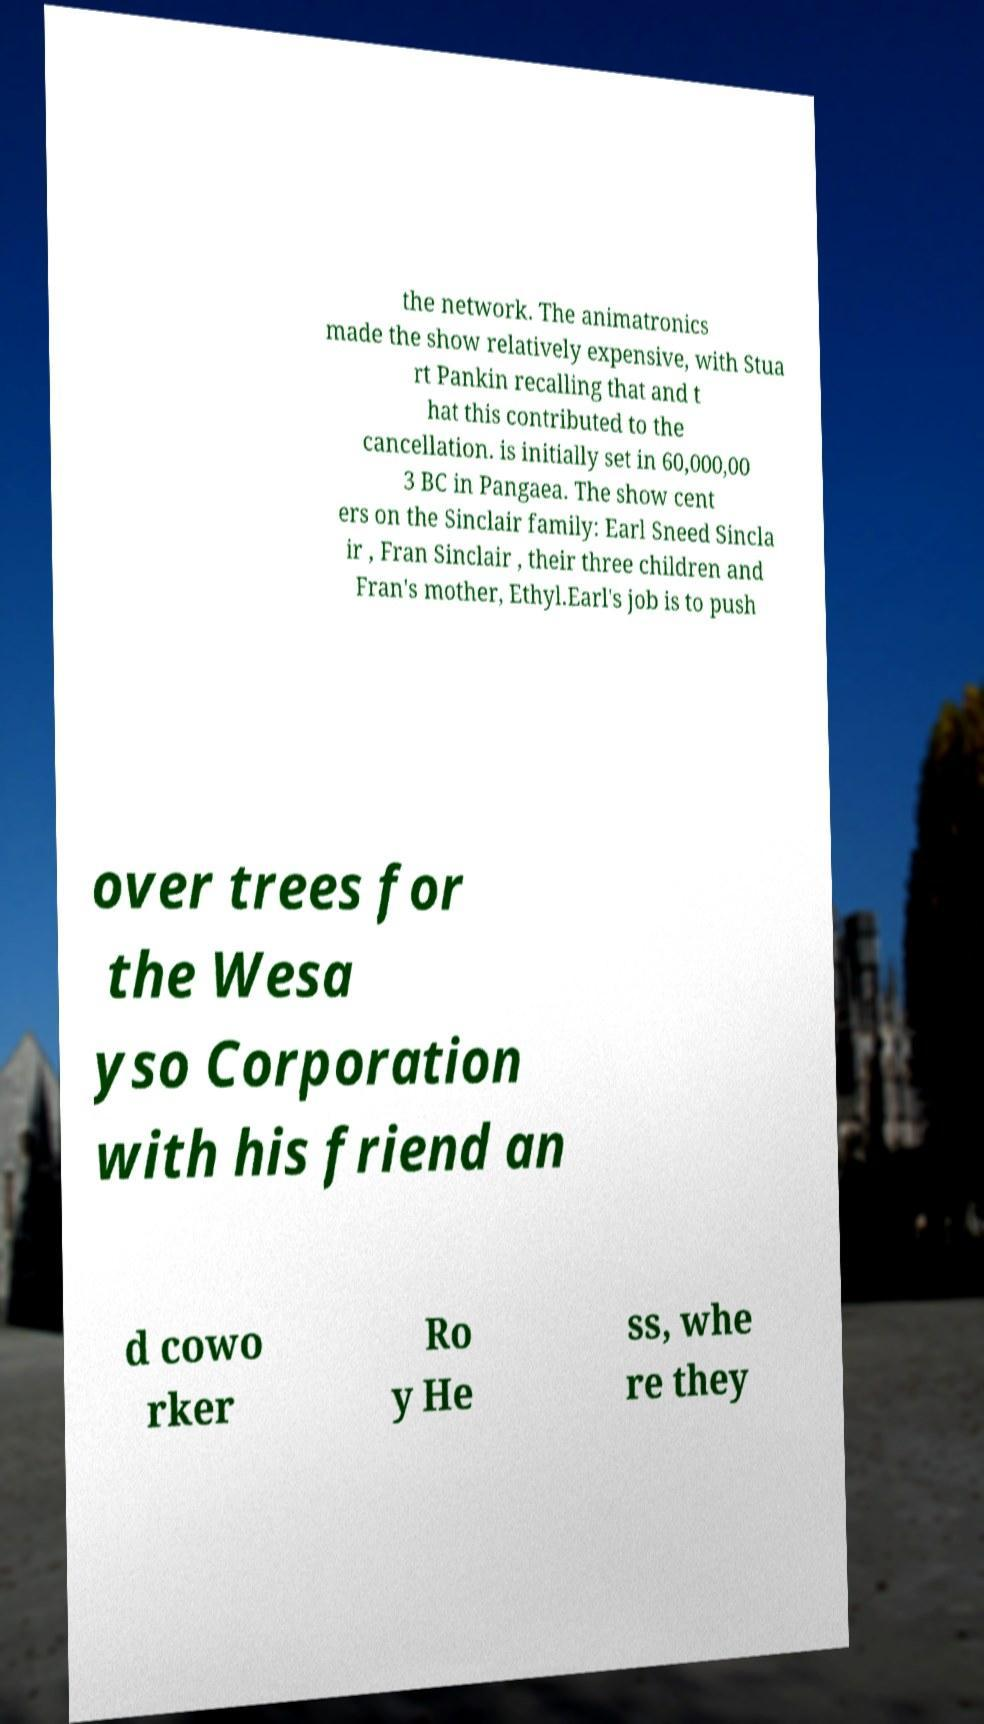Could you extract and type out the text from this image? the network. The animatronics made the show relatively expensive, with Stua rt Pankin recalling that and t hat this contributed to the cancellation. is initially set in 60,000,00 3 BC in Pangaea. The show cent ers on the Sinclair family: Earl Sneed Sincla ir , Fran Sinclair , their three children and Fran's mother, Ethyl.Earl's job is to push over trees for the Wesa yso Corporation with his friend an d cowo rker Ro y He ss, whe re they 